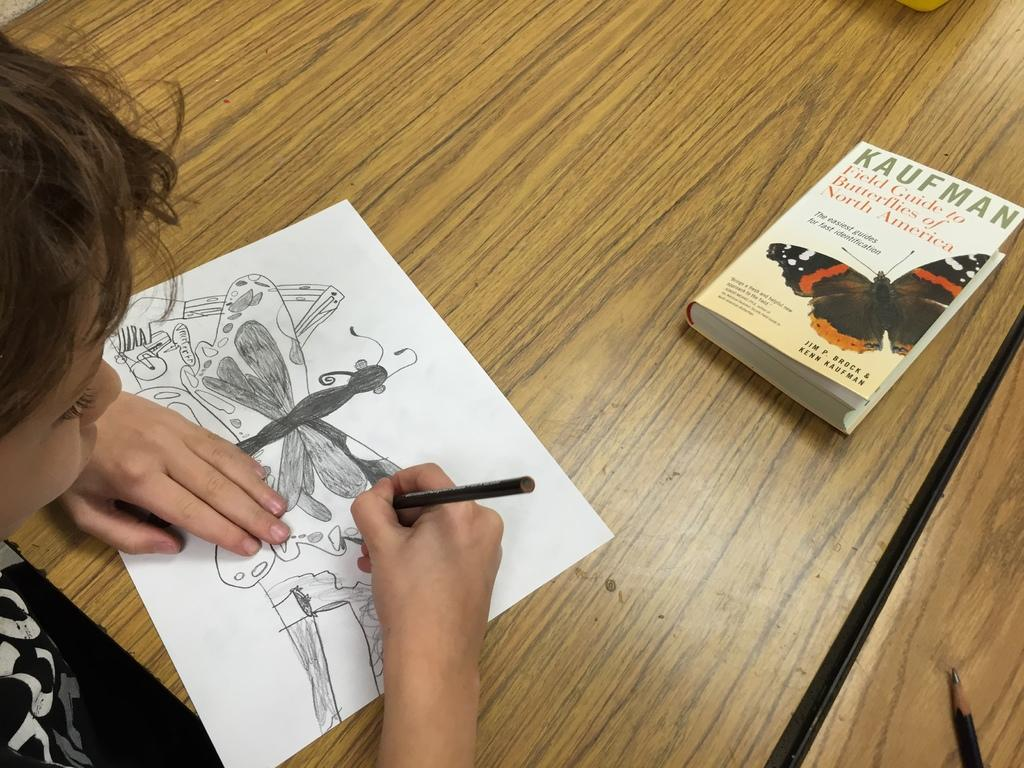What is the kid doing in the image? The kid is drawing a sketch on a paper. What tool is the kid using for drawing? The kid is using a pencil for drawing. Where is the drawing taking place? The drawing is on a table. What else can be seen on the table? There is a book and a pencil on the table. What type of machine is the kid using to draw the sketch? There is no machine present in the image; the kid is using a pencil for drawing. Can you describe the throne that the kid is sitting on while drawing? There is no throne present in the image; the kid is sitting at a table while drawing. 